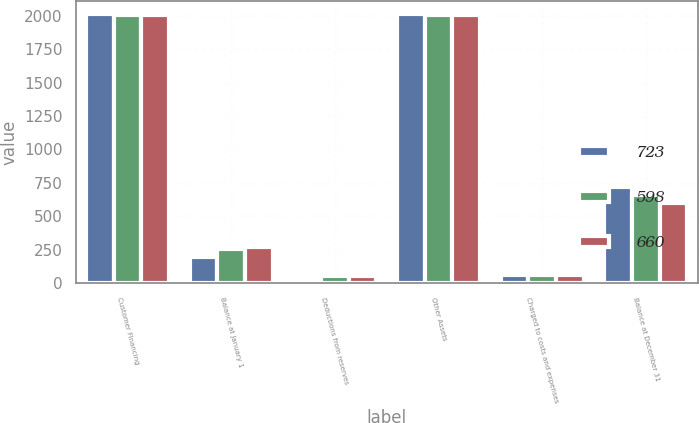<chart> <loc_0><loc_0><loc_500><loc_500><stacked_bar_chart><ecel><fcel>Customer Financing<fcel>Balance at January 1<fcel>Deductions from reserves<fcel>Other Assets<fcel>Charged to costs and expenses<fcel>Balance at December 31<nl><fcel>723<fcel>2008<fcel>195<fcel>10<fcel>2008<fcel>63<fcel>723<nl><fcel>598<fcel>2007<fcel>254<fcel>59<fcel>2007<fcel>63<fcel>660<nl><fcel>660<fcel>2006<fcel>274<fcel>52<fcel>2006<fcel>62<fcel>598<nl></chart> 